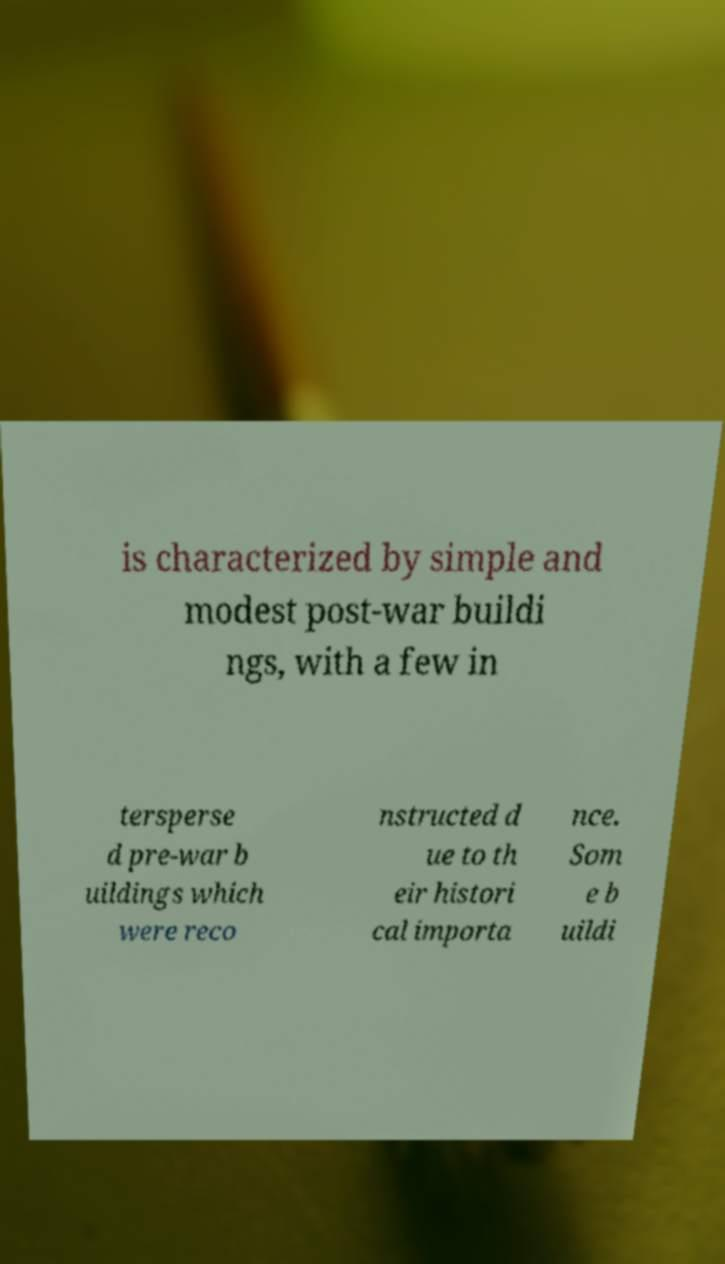What messages or text are displayed in this image? I need them in a readable, typed format. is characterized by simple and modest post-war buildi ngs, with a few in tersperse d pre-war b uildings which were reco nstructed d ue to th eir histori cal importa nce. Som e b uildi 